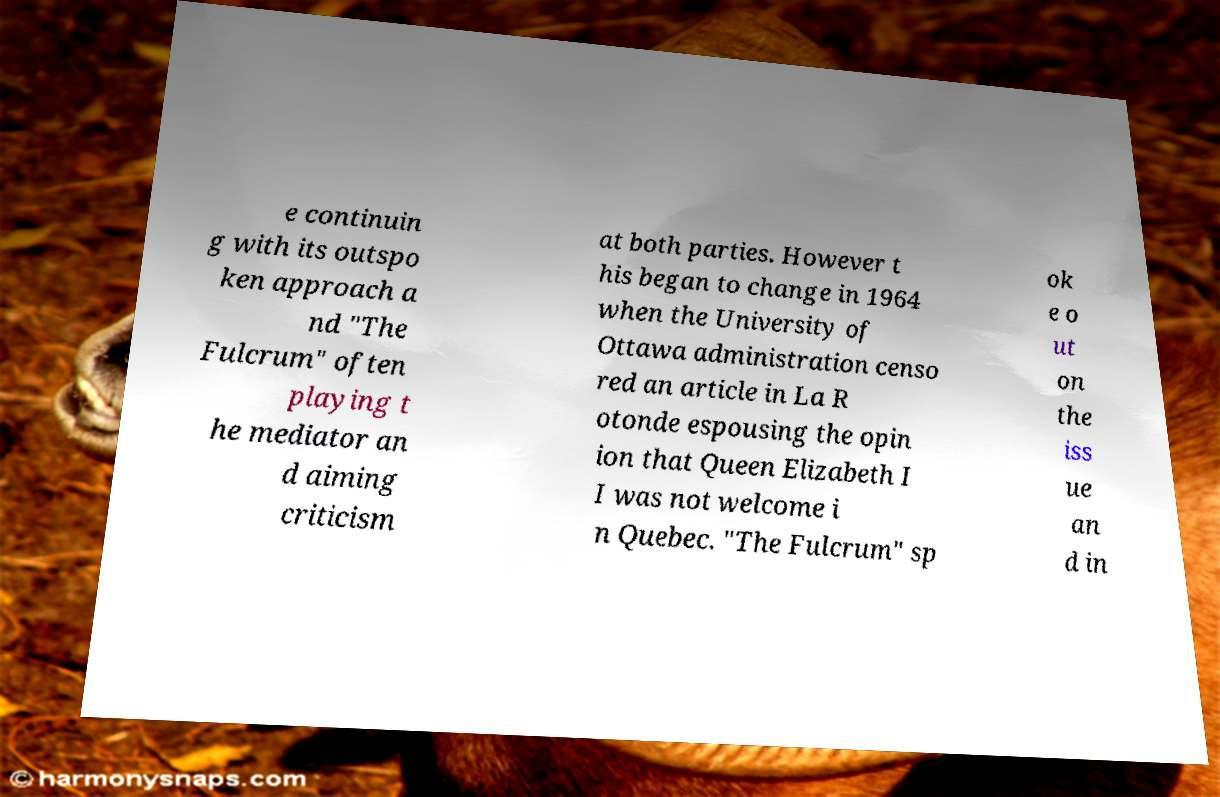Please identify and transcribe the text found in this image. e continuin g with its outspo ken approach a nd "The Fulcrum" often playing t he mediator an d aiming criticism at both parties. However t his began to change in 1964 when the University of Ottawa administration censo red an article in La R otonde espousing the opin ion that Queen Elizabeth I I was not welcome i n Quebec. "The Fulcrum" sp ok e o ut on the iss ue an d in 